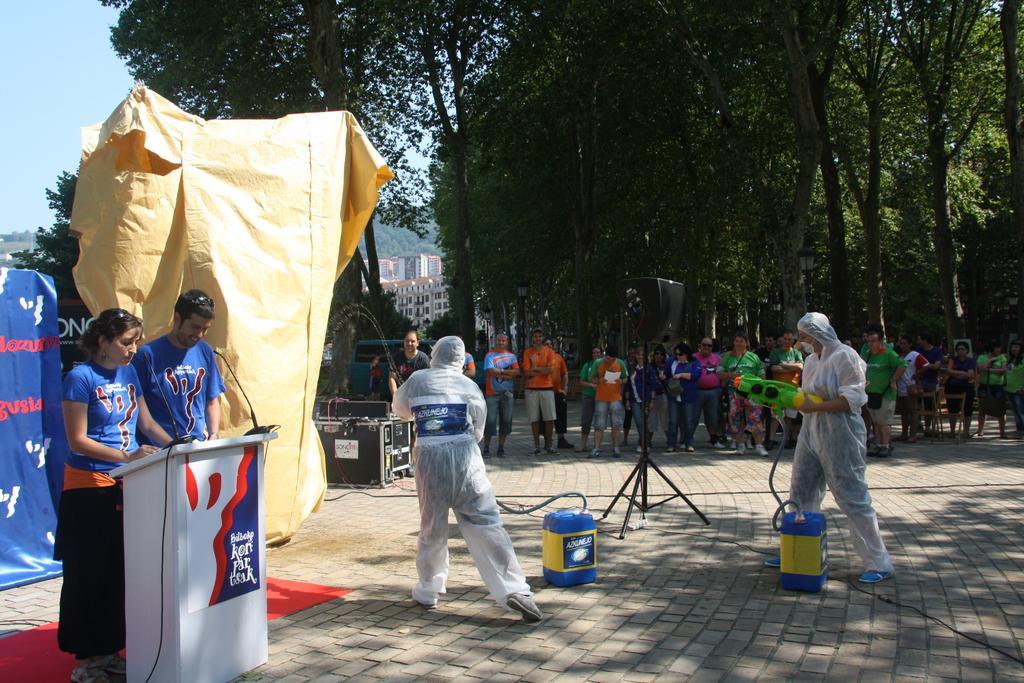In one or two sentences, can you explain what this image depicts? In this image I can see number of people are standing and in the centre I can see two persons are wearing white colour things. I can also see one of them is holding a water gun and near them I can see a blue and yellow colour thing. I can also see most of people are wearing green colour dress. On the left side of the image I can see a podium and on it I can see a board, two mics and a wire. I can also see something is written on the board and near the podium I can see two persons are standing. I can see both of them are wearing blue colour dress. On the left side of the image I can see two boards, a yellow colour cover, few black colour boxes and on these boards I can see something is written. In the background I can see number of trees, few buildings and the sky. I can also see a black colour thing in the centre of the image. 